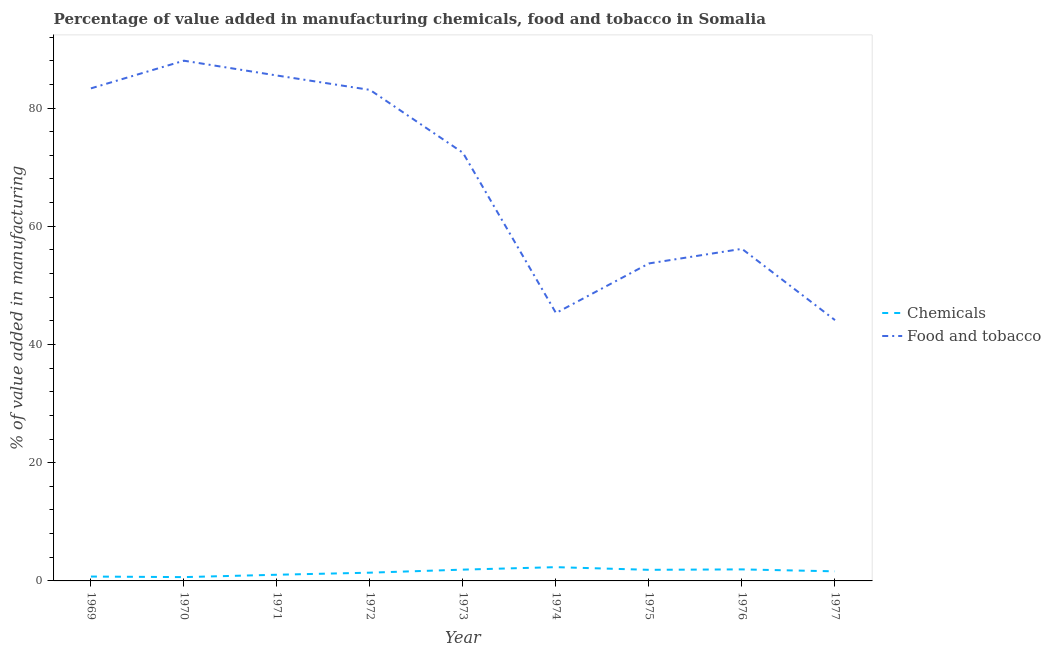How many different coloured lines are there?
Your answer should be very brief. 2. Does the line corresponding to value added by  manufacturing chemicals intersect with the line corresponding to value added by manufacturing food and tobacco?
Your answer should be very brief. No. Is the number of lines equal to the number of legend labels?
Your response must be concise. Yes. What is the value added by manufacturing food and tobacco in 1977?
Make the answer very short. 44.12. Across all years, what is the maximum value added by  manufacturing chemicals?
Your response must be concise. 2.33. Across all years, what is the minimum value added by  manufacturing chemicals?
Offer a terse response. 0.64. In which year was the value added by  manufacturing chemicals maximum?
Provide a short and direct response. 1974. What is the total value added by  manufacturing chemicals in the graph?
Provide a succinct answer. 13.52. What is the difference between the value added by manufacturing food and tobacco in 1973 and that in 1977?
Your answer should be compact. 28.31. What is the difference between the value added by  manufacturing chemicals in 1976 and the value added by manufacturing food and tobacco in 1975?
Provide a succinct answer. -51.76. What is the average value added by  manufacturing chemicals per year?
Keep it short and to the point. 1.5. In the year 1977, what is the difference between the value added by  manufacturing chemicals and value added by manufacturing food and tobacco?
Offer a terse response. -42.5. What is the ratio of the value added by manufacturing food and tobacco in 1970 to that in 1973?
Ensure brevity in your answer.  1.22. Is the difference between the value added by  manufacturing chemicals in 1971 and 1975 greater than the difference between the value added by manufacturing food and tobacco in 1971 and 1975?
Give a very brief answer. No. What is the difference between the highest and the second highest value added by  manufacturing chemicals?
Provide a succinct answer. 0.38. What is the difference between the highest and the lowest value added by manufacturing food and tobacco?
Make the answer very short. 43.89. Is the value added by manufacturing food and tobacco strictly less than the value added by  manufacturing chemicals over the years?
Offer a terse response. No. How many lines are there?
Provide a succinct answer. 2. What is the difference between two consecutive major ticks on the Y-axis?
Offer a very short reply. 20. Are the values on the major ticks of Y-axis written in scientific E-notation?
Your answer should be very brief. No. Where does the legend appear in the graph?
Offer a terse response. Center right. How many legend labels are there?
Your answer should be very brief. 2. What is the title of the graph?
Ensure brevity in your answer.  Percentage of value added in manufacturing chemicals, food and tobacco in Somalia. What is the label or title of the X-axis?
Offer a very short reply. Year. What is the label or title of the Y-axis?
Provide a short and direct response. % of value added in manufacturing. What is the % of value added in manufacturing of Chemicals in 1969?
Ensure brevity in your answer.  0.74. What is the % of value added in manufacturing in Food and tobacco in 1969?
Your answer should be very brief. 83.33. What is the % of value added in manufacturing in Chemicals in 1970?
Provide a succinct answer. 0.64. What is the % of value added in manufacturing in Food and tobacco in 1970?
Provide a short and direct response. 88.01. What is the % of value added in manufacturing of Chemicals in 1971?
Ensure brevity in your answer.  1.05. What is the % of value added in manufacturing in Food and tobacco in 1971?
Give a very brief answer. 85.5. What is the % of value added in manufacturing of Chemicals in 1972?
Your answer should be compact. 1.4. What is the % of value added in manufacturing in Food and tobacco in 1972?
Give a very brief answer. 83.07. What is the % of value added in manufacturing in Chemicals in 1973?
Your response must be concise. 1.91. What is the % of value added in manufacturing in Food and tobacco in 1973?
Provide a succinct answer. 72.43. What is the % of value added in manufacturing in Chemicals in 1974?
Offer a very short reply. 2.33. What is the % of value added in manufacturing of Food and tobacco in 1974?
Your answer should be very brief. 45.32. What is the % of value added in manufacturing in Chemicals in 1975?
Ensure brevity in your answer.  1.88. What is the % of value added in manufacturing of Food and tobacco in 1975?
Make the answer very short. 53.71. What is the % of value added in manufacturing of Chemicals in 1976?
Provide a succinct answer. 1.95. What is the % of value added in manufacturing of Food and tobacco in 1976?
Offer a terse response. 56.18. What is the % of value added in manufacturing in Chemicals in 1977?
Give a very brief answer. 1.62. What is the % of value added in manufacturing in Food and tobacco in 1977?
Your answer should be compact. 44.12. Across all years, what is the maximum % of value added in manufacturing of Chemicals?
Provide a short and direct response. 2.33. Across all years, what is the maximum % of value added in manufacturing of Food and tobacco?
Provide a short and direct response. 88.01. Across all years, what is the minimum % of value added in manufacturing in Chemicals?
Give a very brief answer. 0.64. Across all years, what is the minimum % of value added in manufacturing of Food and tobacco?
Offer a terse response. 44.12. What is the total % of value added in manufacturing in Chemicals in the graph?
Provide a succinct answer. 13.52. What is the total % of value added in manufacturing of Food and tobacco in the graph?
Make the answer very short. 611.66. What is the difference between the % of value added in manufacturing in Chemicals in 1969 and that in 1970?
Your response must be concise. 0.1. What is the difference between the % of value added in manufacturing in Food and tobacco in 1969 and that in 1970?
Keep it short and to the point. -4.68. What is the difference between the % of value added in manufacturing in Chemicals in 1969 and that in 1971?
Offer a terse response. -0.3. What is the difference between the % of value added in manufacturing of Food and tobacco in 1969 and that in 1971?
Your answer should be compact. -2.17. What is the difference between the % of value added in manufacturing of Chemicals in 1969 and that in 1972?
Provide a short and direct response. -0.66. What is the difference between the % of value added in manufacturing of Food and tobacco in 1969 and that in 1972?
Your response must be concise. 0.26. What is the difference between the % of value added in manufacturing in Chemicals in 1969 and that in 1973?
Provide a short and direct response. -1.17. What is the difference between the % of value added in manufacturing in Food and tobacco in 1969 and that in 1973?
Make the answer very short. 10.9. What is the difference between the % of value added in manufacturing in Chemicals in 1969 and that in 1974?
Your answer should be compact. -1.59. What is the difference between the % of value added in manufacturing in Food and tobacco in 1969 and that in 1974?
Provide a succinct answer. 38. What is the difference between the % of value added in manufacturing of Chemicals in 1969 and that in 1975?
Ensure brevity in your answer.  -1.14. What is the difference between the % of value added in manufacturing of Food and tobacco in 1969 and that in 1975?
Offer a very short reply. 29.61. What is the difference between the % of value added in manufacturing in Chemicals in 1969 and that in 1976?
Make the answer very short. -1.21. What is the difference between the % of value added in manufacturing in Food and tobacco in 1969 and that in 1976?
Ensure brevity in your answer.  27.15. What is the difference between the % of value added in manufacturing of Chemicals in 1969 and that in 1977?
Your answer should be very brief. -0.88. What is the difference between the % of value added in manufacturing in Food and tobacco in 1969 and that in 1977?
Provide a short and direct response. 39.21. What is the difference between the % of value added in manufacturing in Chemicals in 1970 and that in 1971?
Give a very brief answer. -0.4. What is the difference between the % of value added in manufacturing in Food and tobacco in 1970 and that in 1971?
Your answer should be very brief. 2.51. What is the difference between the % of value added in manufacturing of Chemicals in 1970 and that in 1972?
Your answer should be very brief. -0.75. What is the difference between the % of value added in manufacturing in Food and tobacco in 1970 and that in 1972?
Make the answer very short. 4.94. What is the difference between the % of value added in manufacturing of Chemicals in 1970 and that in 1973?
Make the answer very short. -1.27. What is the difference between the % of value added in manufacturing of Food and tobacco in 1970 and that in 1973?
Offer a terse response. 15.58. What is the difference between the % of value added in manufacturing of Chemicals in 1970 and that in 1974?
Make the answer very short. -1.68. What is the difference between the % of value added in manufacturing in Food and tobacco in 1970 and that in 1974?
Your answer should be very brief. 42.68. What is the difference between the % of value added in manufacturing in Chemicals in 1970 and that in 1975?
Keep it short and to the point. -1.23. What is the difference between the % of value added in manufacturing of Food and tobacco in 1970 and that in 1975?
Offer a very short reply. 34.3. What is the difference between the % of value added in manufacturing of Chemicals in 1970 and that in 1976?
Make the answer very short. -1.31. What is the difference between the % of value added in manufacturing in Food and tobacco in 1970 and that in 1976?
Offer a very short reply. 31.83. What is the difference between the % of value added in manufacturing of Chemicals in 1970 and that in 1977?
Offer a very short reply. -0.98. What is the difference between the % of value added in manufacturing of Food and tobacco in 1970 and that in 1977?
Provide a short and direct response. 43.89. What is the difference between the % of value added in manufacturing in Chemicals in 1971 and that in 1972?
Keep it short and to the point. -0.35. What is the difference between the % of value added in manufacturing of Food and tobacco in 1971 and that in 1972?
Keep it short and to the point. 2.43. What is the difference between the % of value added in manufacturing of Chemicals in 1971 and that in 1973?
Your answer should be very brief. -0.87. What is the difference between the % of value added in manufacturing of Food and tobacco in 1971 and that in 1973?
Provide a succinct answer. 13.07. What is the difference between the % of value added in manufacturing of Chemicals in 1971 and that in 1974?
Give a very brief answer. -1.28. What is the difference between the % of value added in manufacturing of Food and tobacco in 1971 and that in 1974?
Give a very brief answer. 40.18. What is the difference between the % of value added in manufacturing in Chemicals in 1971 and that in 1975?
Your answer should be very brief. -0.83. What is the difference between the % of value added in manufacturing in Food and tobacco in 1971 and that in 1975?
Your response must be concise. 31.79. What is the difference between the % of value added in manufacturing of Chemicals in 1971 and that in 1976?
Your answer should be very brief. -0.91. What is the difference between the % of value added in manufacturing in Food and tobacco in 1971 and that in 1976?
Ensure brevity in your answer.  29.32. What is the difference between the % of value added in manufacturing of Chemicals in 1971 and that in 1977?
Offer a very short reply. -0.58. What is the difference between the % of value added in manufacturing of Food and tobacco in 1971 and that in 1977?
Give a very brief answer. 41.38. What is the difference between the % of value added in manufacturing in Chemicals in 1972 and that in 1973?
Offer a terse response. -0.52. What is the difference between the % of value added in manufacturing of Food and tobacco in 1972 and that in 1973?
Your response must be concise. 10.64. What is the difference between the % of value added in manufacturing of Chemicals in 1972 and that in 1974?
Your response must be concise. -0.93. What is the difference between the % of value added in manufacturing in Food and tobacco in 1972 and that in 1974?
Your answer should be very brief. 37.75. What is the difference between the % of value added in manufacturing in Chemicals in 1972 and that in 1975?
Give a very brief answer. -0.48. What is the difference between the % of value added in manufacturing in Food and tobacco in 1972 and that in 1975?
Give a very brief answer. 29.36. What is the difference between the % of value added in manufacturing of Chemicals in 1972 and that in 1976?
Ensure brevity in your answer.  -0.56. What is the difference between the % of value added in manufacturing of Food and tobacco in 1972 and that in 1976?
Give a very brief answer. 26.89. What is the difference between the % of value added in manufacturing of Chemicals in 1972 and that in 1977?
Your response must be concise. -0.23. What is the difference between the % of value added in manufacturing of Food and tobacco in 1972 and that in 1977?
Offer a very short reply. 38.95. What is the difference between the % of value added in manufacturing of Chemicals in 1973 and that in 1974?
Offer a very short reply. -0.42. What is the difference between the % of value added in manufacturing in Food and tobacco in 1973 and that in 1974?
Your response must be concise. 27.1. What is the difference between the % of value added in manufacturing of Chemicals in 1973 and that in 1975?
Provide a succinct answer. 0.03. What is the difference between the % of value added in manufacturing in Food and tobacco in 1973 and that in 1975?
Offer a terse response. 18.72. What is the difference between the % of value added in manufacturing of Chemicals in 1973 and that in 1976?
Give a very brief answer. -0.04. What is the difference between the % of value added in manufacturing of Food and tobacco in 1973 and that in 1976?
Give a very brief answer. 16.25. What is the difference between the % of value added in manufacturing in Chemicals in 1973 and that in 1977?
Your answer should be very brief. 0.29. What is the difference between the % of value added in manufacturing in Food and tobacco in 1973 and that in 1977?
Your answer should be compact. 28.31. What is the difference between the % of value added in manufacturing of Chemicals in 1974 and that in 1975?
Give a very brief answer. 0.45. What is the difference between the % of value added in manufacturing in Food and tobacco in 1974 and that in 1975?
Ensure brevity in your answer.  -8.39. What is the difference between the % of value added in manufacturing of Chemicals in 1974 and that in 1976?
Your answer should be compact. 0.38. What is the difference between the % of value added in manufacturing in Food and tobacco in 1974 and that in 1976?
Your answer should be very brief. -10.85. What is the difference between the % of value added in manufacturing in Chemicals in 1974 and that in 1977?
Keep it short and to the point. 0.71. What is the difference between the % of value added in manufacturing of Food and tobacco in 1974 and that in 1977?
Make the answer very short. 1.21. What is the difference between the % of value added in manufacturing of Chemicals in 1975 and that in 1976?
Keep it short and to the point. -0.07. What is the difference between the % of value added in manufacturing of Food and tobacco in 1975 and that in 1976?
Make the answer very short. -2.47. What is the difference between the % of value added in manufacturing of Chemicals in 1975 and that in 1977?
Ensure brevity in your answer.  0.26. What is the difference between the % of value added in manufacturing of Food and tobacco in 1975 and that in 1977?
Give a very brief answer. 9.59. What is the difference between the % of value added in manufacturing in Chemicals in 1976 and that in 1977?
Provide a short and direct response. 0.33. What is the difference between the % of value added in manufacturing of Food and tobacco in 1976 and that in 1977?
Make the answer very short. 12.06. What is the difference between the % of value added in manufacturing in Chemicals in 1969 and the % of value added in manufacturing in Food and tobacco in 1970?
Make the answer very short. -87.27. What is the difference between the % of value added in manufacturing of Chemicals in 1969 and the % of value added in manufacturing of Food and tobacco in 1971?
Ensure brevity in your answer.  -84.76. What is the difference between the % of value added in manufacturing in Chemicals in 1969 and the % of value added in manufacturing in Food and tobacco in 1972?
Your response must be concise. -82.33. What is the difference between the % of value added in manufacturing of Chemicals in 1969 and the % of value added in manufacturing of Food and tobacco in 1973?
Offer a very short reply. -71.69. What is the difference between the % of value added in manufacturing of Chemicals in 1969 and the % of value added in manufacturing of Food and tobacco in 1974?
Ensure brevity in your answer.  -44.58. What is the difference between the % of value added in manufacturing of Chemicals in 1969 and the % of value added in manufacturing of Food and tobacco in 1975?
Keep it short and to the point. -52.97. What is the difference between the % of value added in manufacturing in Chemicals in 1969 and the % of value added in manufacturing in Food and tobacco in 1976?
Your answer should be very brief. -55.44. What is the difference between the % of value added in manufacturing in Chemicals in 1969 and the % of value added in manufacturing in Food and tobacco in 1977?
Ensure brevity in your answer.  -43.38. What is the difference between the % of value added in manufacturing of Chemicals in 1970 and the % of value added in manufacturing of Food and tobacco in 1971?
Your response must be concise. -84.86. What is the difference between the % of value added in manufacturing of Chemicals in 1970 and the % of value added in manufacturing of Food and tobacco in 1972?
Your answer should be compact. -82.42. What is the difference between the % of value added in manufacturing of Chemicals in 1970 and the % of value added in manufacturing of Food and tobacco in 1973?
Make the answer very short. -71.78. What is the difference between the % of value added in manufacturing of Chemicals in 1970 and the % of value added in manufacturing of Food and tobacco in 1974?
Offer a very short reply. -44.68. What is the difference between the % of value added in manufacturing of Chemicals in 1970 and the % of value added in manufacturing of Food and tobacco in 1975?
Your answer should be compact. -53.07. What is the difference between the % of value added in manufacturing of Chemicals in 1970 and the % of value added in manufacturing of Food and tobacco in 1976?
Offer a very short reply. -55.53. What is the difference between the % of value added in manufacturing of Chemicals in 1970 and the % of value added in manufacturing of Food and tobacco in 1977?
Provide a succinct answer. -43.47. What is the difference between the % of value added in manufacturing of Chemicals in 1971 and the % of value added in manufacturing of Food and tobacco in 1972?
Make the answer very short. -82.02. What is the difference between the % of value added in manufacturing of Chemicals in 1971 and the % of value added in manufacturing of Food and tobacco in 1973?
Provide a short and direct response. -71.38. What is the difference between the % of value added in manufacturing in Chemicals in 1971 and the % of value added in manufacturing in Food and tobacco in 1974?
Keep it short and to the point. -44.28. What is the difference between the % of value added in manufacturing in Chemicals in 1971 and the % of value added in manufacturing in Food and tobacco in 1975?
Provide a succinct answer. -52.67. What is the difference between the % of value added in manufacturing of Chemicals in 1971 and the % of value added in manufacturing of Food and tobacco in 1976?
Provide a succinct answer. -55.13. What is the difference between the % of value added in manufacturing in Chemicals in 1971 and the % of value added in manufacturing in Food and tobacco in 1977?
Keep it short and to the point. -43.07. What is the difference between the % of value added in manufacturing in Chemicals in 1972 and the % of value added in manufacturing in Food and tobacco in 1973?
Give a very brief answer. -71.03. What is the difference between the % of value added in manufacturing in Chemicals in 1972 and the % of value added in manufacturing in Food and tobacco in 1974?
Your answer should be very brief. -43.93. What is the difference between the % of value added in manufacturing of Chemicals in 1972 and the % of value added in manufacturing of Food and tobacco in 1975?
Keep it short and to the point. -52.32. What is the difference between the % of value added in manufacturing of Chemicals in 1972 and the % of value added in manufacturing of Food and tobacco in 1976?
Provide a short and direct response. -54.78. What is the difference between the % of value added in manufacturing of Chemicals in 1972 and the % of value added in manufacturing of Food and tobacco in 1977?
Ensure brevity in your answer.  -42.72. What is the difference between the % of value added in manufacturing of Chemicals in 1973 and the % of value added in manufacturing of Food and tobacco in 1974?
Provide a succinct answer. -43.41. What is the difference between the % of value added in manufacturing of Chemicals in 1973 and the % of value added in manufacturing of Food and tobacco in 1975?
Provide a succinct answer. -51.8. What is the difference between the % of value added in manufacturing in Chemicals in 1973 and the % of value added in manufacturing in Food and tobacco in 1976?
Make the answer very short. -54.27. What is the difference between the % of value added in manufacturing of Chemicals in 1973 and the % of value added in manufacturing of Food and tobacco in 1977?
Offer a terse response. -42.21. What is the difference between the % of value added in manufacturing of Chemicals in 1974 and the % of value added in manufacturing of Food and tobacco in 1975?
Provide a succinct answer. -51.38. What is the difference between the % of value added in manufacturing in Chemicals in 1974 and the % of value added in manufacturing in Food and tobacco in 1976?
Keep it short and to the point. -53.85. What is the difference between the % of value added in manufacturing in Chemicals in 1974 and the % of value added in manufacturing in Food and tobacco in 1977?
Your answer should be compact. -41.79. What is the difference between the % of value added in manufacturing of Chemicals in 1975 and the % of value added in manufacturing of Food and tobacco in 1976?
Offer a very short reply. -54.3. What is the difference between the % of value added in manufacturing in Chemicals in 1975 and the % of value added in manufacturing in Food and tobacco in 1977?
Make the answer very short. -42.24. What is the difference between the % of value added in manufacturing in Chemicals in 1976 and the % of value added in manufacturing in Food and tobacco in 1977?
Give a very brief answer. -42.17. What is the average % of value added in manufacturing in Chemicals per year?
Your response must be concise. 1.5. What is the average % of value added in manufacturing in Food and tobacco per year?
Your answer should be very brief. 67.96. In the year 1969, what is the difference between the % of value added in manufacturing in Chemicals and % of value added in manufacturing in Food and tobacco?
Offer a very short reply. -82.59. In the year 1970, what is the difference between the % of value added in manufacturing of Chemicals and % of value added in manufacturing of Food and tobacco?
Offer a very short reply. -87.36. In the year 1971, what is the difference between the % of value added in manufacturing of Chemicals and % of value added in manufacturing of Food and tobacco?
Give a very brief answer. -84.46. In the year 1972, what is the difference between the % of value added in manufacturing in Chemicals and % of value added in manufacturing in Food and tobacco?
Offer a terse response. -81.67. In the year 1973, what is the difference between the % of value added in manufacturing of Chemicals and % of value added in manufacturing of Food and tobacco?
Offer a terse response. -70.52. In the year 1974, what is the difference between the % of value added in manufacturing of Chemicals and % of value added in manufacturing of Food and tobacco?
Your response must be concise. -42.99. In the year 1975, what is the difference between the % of value added in manufacturing in Chemicals and % of value added in manufacturing in Food and tobacco?
Provide a succinct answer. -51.83. In the year 1976, what is the difference between the % of value added in manufacturing of Chemicals and % of value added in manufacturing of Food and tobacco?
Make the answer very short. -54.23. In the year 1977, what is the difference between the % of value added in manufacturing of Chemicals and % of value added in manufacturing of Food and tobacco?
Keep it short and to the point. -42.5. What is the ratio of the % of value added in manufacturing of Chemicals in 1969 to that in 1970?
Offer a terse response. 1.15. What is the ratio of the % of value added in manufacturing in Food and tobacco in 1969 to that in 1970?
Your answer should be compact. 0.95. What is the ratio of the % of value added in manufacturing in Chemicals in 1969 to that in 1971?
Give a very brief answer. 0.71. What is the ratio of the % of value added in manufacturing of Food and tobacco in 1969 to that in 1971?
Give a very brief answer. 0.97. What is the ratio of the % of value added in manufacturing of Chemicals in 1969 to that in 1972?
Ensure brevity in your answer.  0.53. What is the ratio of the % of value added in manufacturing of Chemicals in 1969 to that in 1973?
Your answer should be compact. 0.39. What is the ratio of the % of value added in manufacturing in Food and tobacco in 1969 to that in 1973?
Keep it short and to the point. 1.15. What is the ratio of the % of value added in manufacturing of Chemicals in 1969 to that in 1974?
Ensure brevity in your answer.  0.32. What is the ratio of the % of value added in manufacturing in Food and tobacco in 1969 to that in 1974?
Provide a short and direct response. 1.84. What is the ratio of the % of value added in manufacturing in Chemicals in 1969 to that in 1975?
Your answer should be very brief. 0.39. What is the ratio of the % of value added in manufacturing in Food and tobacco in 1969 to that in 1975?
Your answer should be compact. 1.55. What is the ratio of the % of value added in manufacturing in Chemicals in 1969 to that in 1976?
Provide a succinct answer. 0.38. What is the ratio of the % of value added in manufacturing in Food and tobacco in 1969 to that in 1976?
Offer a very short reply. 1.48. What is the ratio of the % of value added in manufacturing of Chemicals in 1969 to that in 1977?
Give a very brief answer. 0.46. What is the ratio of the % of value added in manufacturing in Food and tobacco in 1969 to that in 1977?
Give a very brief answer. 1.89. What is the ratio of the % of value added in manufacturing in Chemicals in 1970 to that in 1971?
Keep it short and to the point. 0.62. What is the ratio of the % of value added in manufacturing of Food and tobacco in 1970 to that in 1971?
Your answer should be compact. 1.03. What is the ratio of the % of value added in manufacturing of Chemicals in 1970 to that in 1972?
Your response must be concise. 0.46. What is the ratio of the % of value added in manufacturing in Food and tobacco in 1970 to that in 1972?
Provide a succinct answer. 1.06. What is the ratio of the % of value added in manufacturing of Chemicals in 1970 to that in 1973?
Make the answer very short. 0.34. What is the ratio of the % of value added in manufacturing in Food and tobacco in 1970 to that in 1973?
Ensure brevity in your answer.  1.22. What is the ratio of the % of value added in manufacturing in Chemicals in 1970 to that in 1974?
Your response must be concise. 0.28. What is the ratio of the % of value added in manufacturing of Food and tobacco in 1970 to that in 1974?
Give a very brief answer. 1.94. What is the ratio of the % of value added in manufacturing of Chemicals in 1970 to that in 1975?
Keep it short and to the point. 0.34. What is the ratio of the % of value added in manufacturing in Food and tobacco in 1970 to that in 1975?
Ensure brevity in your answer.  1.64. What is the ratio of the % of value added in manufacturing of Chemicals in 1970 to that in 1976?
Make the answer very short. 0.33. What is the ratio of the % of value added in manufacturing of Food and tobacco in 1970 to that in 1976?
Provide a short and direct response. 1.57. What is the ratio of the % of value added in manufacturing in Chemicals in 1970 to that in 1977?
Your answer should be compact. 0.4. What is the ratio of the % of value added in manufacturing in Food and tobacco in 1970 to that in 1977?
Your answer should be compact. 1.99. What is the ratio of the % of value added in manufacturing in Chemicals in 1971 to that in 1972?
Your response must be concise. 0.75. What is the ratio of the % of value added in manufacturing in Food and tobacco in 1971 to that in 1972?
Your response must be concise. 1.03. What is the ratio of the % of value added in manufacturing of Chemicals in 1971 to that in 1973?
Your answer should be compact. 0.55. What is the ratio of the % of value added in manufacturing in Food and tobacco in 1971 to that in 1973?
Your answer should be very brief. 1.18. What is the ratio of the % of value added in manufacturing in Chemicals in 1971 to that in 1974?
Give a very brief answer. 0.45. What is the ratio of the % of value added in manufacturing of Food and tobacco in 1971 to that in 1974?
Your answer should be very brief. 1.89. What is the ratio of the % of value added in manufacturing of Chemicals in 1971 to that in 1975?
Your answer should be very brief. 0.56. What is the ratio of the % of value added in manufacturing in Food and tobacco in 1971 to that in 1975?
Ensure brevity in your answer.  1.59. What is the ratio of the % of value added in manufacturing in Chemicals in 1971 to that in 1976?
Keep it short and to the point. 0.54. What is the ratio of the % of value added in manufacturing in Food and tobacco in 1971 to that in 1976?
Offer a terse response. 1.52. What is the ratio of the % of value added in manufacturing of Chemicals in 1971 to that in 1977?
Keep it short and to the point. 0.64. What is the ratio of the % of value added in manufacturing in Food and tobacco in 1971 to that in 1977?
Make the answer very short. 1.94. What is the ratio of the % of value added in manufacturing of Chemicals in 1972 to that in 1973?
Keep it short and to the point. 0.73. What is the ratio of the % of value added in manufacturing of Food and tobacco in 1972 to that in 1973?
Offer a very short reply. 1.15. What is the ratio of the % of value added in manufacturing of Chemicals in 1972 to that in 1974?
Offer a terse response. 0.6. What is the ratio of the % of value added in manufacturing of Food and tobacco in 1972 to that in 1974?
Keep it short and to the point. 1.83. What is the ratio of the % of value added in manufacturing in Chemicals in 1972 to that in 1975?
Your answer should be compact. 0.74. What is the ratio of the % of value added in manufacturing in Food and tobacco in 1972 to that in 1975?
Offer a very short reply. 1.55. What is the ratio of the % of value added in manufacturing in Chemicals in 1972 to that in 1976?
Offer a very short reply. 0.72. What is the ratio of the % of value added in manufacturing in Food and tobacco in 1972 to that in 1976?
Provide a short and direct response. 1.48. What is the ratio of the % of value added in manufacturing of Chemicals in 1972 to that in 1977?
Provide a succinct answer. 0.86. What is the ratio of the % of value added in manufacturing of Food and tobacco in 1972 to that in 1977?
Provide a short and direct response. 1.88. What is the ratio of the % of value added in manufacturing of Chemicals in 1973 to that in 1974?
Ensure brevity in your answer.  0.82. What is the ratio of the % of value added in manufacturing in Food and tobacco in 1973 to that in 1974?
Provide a short and direct response. 1.6. What is the ratio of the % of value added in manufacturing of Chemicals in 1973 to that in 1975?
Offer a very short reply. 1.02. What is the ratio of the % of value added in manufacturing of Food and tobacco in 1973 to that in 1975?
Your answer should be compact. 1.35. What is the ratio of the % of value added in manufacturing of Chemicals in 1973 to that in 1976?
Ensure brevity in your answer.  0.98. What is the ratio of the % of value added in manufacturing of Food and tobacco in 1973 to that in 1976?
Offer a terse response. 1.29. What is the ratio of the % of value added in manufacturing of Chemicals in 1973 to that in 1977?
Give a very brief answer. 1.18. What is the ratio of the % of value added in manufacturing of Food and tobacco in 1973 to that in 1977?
Keep it short and to the point. 1.64. What is the ratio of the % of value added in manufacturing in Chemicals in 1974 to that in 1975?
Your answer should be very brief. 1.24. What is the ratio of the % of value added in manufacturing of Food and tobacco in 1974 to that in 1975?
Your answer should be compact. 0.84. What is the ratio of the % of value added in manufacturing of Chemicals in 1974 to that in 1976?
Your response must be concise. 1.19. What is the ratio of the % of value added in manufacturing in Food and tobacco in 1974 to that in 1976?
Your answer should be very brief. 0.81. What is the ratio of the % of value added in manufacturing of Chemicals in 1974 to that in 1977?
Your answer should be very brief. 1.44. What is the ratio of the % of value added in manufacturing of Food and tobacco in 1974 to that in 1977?
Your answer should be compact. 1.03. What is the ratio of the % of value added in manufacturing of Chemicals in 1975 to that in 1976?
Ensure brevity in your answer.  0.96. What is the ratio of the % of value added in manufacturing of Food and tobacco in 1975 to that in 1976?
Provide a succinct answer. 0.96. What is the ratio of the % of value added in manufacturing in Chemicals in 1975 to that in 1977?
Your answer should be compact. 1.16. What is the ratio of the % of value added in manufacturing of Food and tobacco in 1975 to that in 1977?
Your answer should be compact. 1.22. What is the ratio of the % of value added in manufacturing in Chemicals in 1976 to that in 1977?
Ensure brevity in your answer.  1.2. What is the ratio of the % of value added in manufacturing of Food and tobacco in 1976 to that in 1977?
Offer a terse response. 1.27. What is the difference between the highest and the second highest % of value added in manufacturing of Chemicals?
Offer a very short reply. 0.38. What is the difference between the highest and the second highest % of value added in manufacturing in Food and tobacco?
Your answer should be very brief. 2.51. What is the difference between the highest and the lowest % of value added in manufacturing in Chemicals?
Your answer should be very brief. 1.68. What is the difference between the highest and the lowest % of value added in manufacturing of Food and tobacco?
Keep it short and to the point. 43.89. 